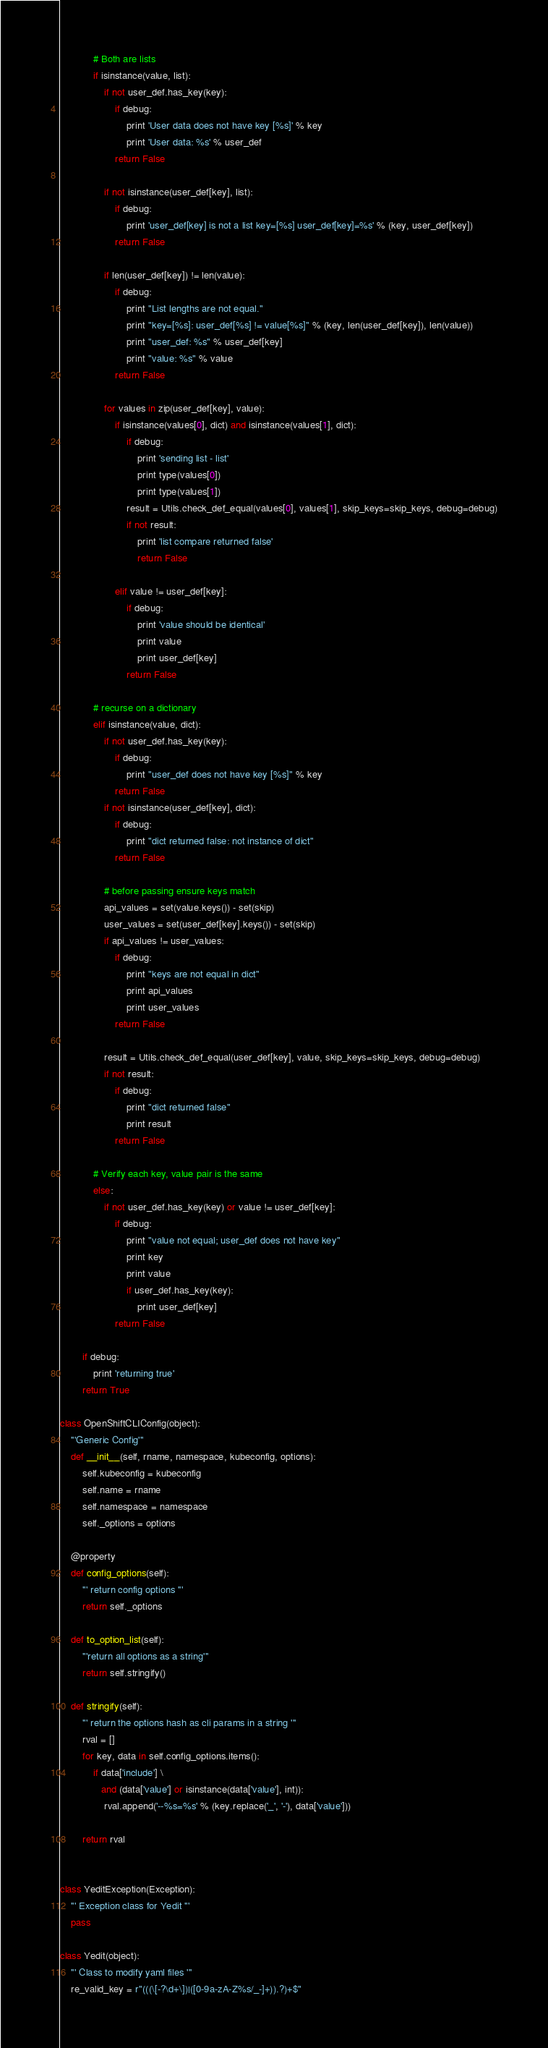Convert code to text. <code><loc_0><loc_0><loc_500><loc_500><_Python_>            # Both are lists
            if isinstance(value, list):
                if not user_def.has_key(key):
                    if debug:
                        print 'User data does not have key [%s]' % key
                        print 'User data: %s' % user_def
                    return False

                if not isinstance(user_def[key], list):
                    if debug:
                        print 'user_def[key] is not a list key=[%s] user_def[key]=%s' % (key, user_def[key])
                    return False

                if len(user_def[key]) != len(value):
                    if debug:
                        print "List lengths are not equal."
                        print "key=[%s]: user_def[%s] != value[%s]" % (key, len(user_def[key]), len(value))
                        print "user_def: %s" % user_def[key]
                        print "value: %s" % value
                    return False

                for values in zip(user_def[key], value):
                    if isinstance(values[0], dict) and isinstance(values[1], dict):
                        if debug:
                            print 'sending list - list'
                            print type(values[0])
                            print type(values[1])
                        result = Utils.check_def_equal(values[0], values[1], skip_keys=skip_keys, debug=debug)
                        if not result:
                            print 'list compare returned false'
                            return False

                    elif value != user_def[key]:
                        if debug:
                            print 'value should be identical'
                            print value
                            print user_def[key]
                        return False

            # recurse on a dictionary
            elif isinstance(value, dict):
                if not user_def.has_key(key):
                    if debug:
                        print "user_def does not have key [%s]" % key
                    return False
                if not isinstance(user_def[key], dict):
                    if debug:
                        print "dict returned false: not instance of dict"
                    return False

                # before passing ensure keys match
                api_values = set(value.keys()) - set(skip)
                user_values = set(user_def[key].keys()) - set(skip)
                if api_values != user_values:
                    if debug:
                        print "keys are not equal in dict"
                        print api_values
                        print user_values
                    return False

                result = Utils.check_def_equal(user_def[key], value, skip_keys=skip_keys, debug=debug)
                if not result:
                    if debug:
                        print "dict returned false"
                        print result
                    return False

            # Verify each key, value pair is the same
            else:
                if not user_def.has_key(key) or value != user_def[key]:
                    if debug:
                        print "value not equal; user_def does not have key"
                        print key
                        print value
                        if user_def.has_key(key):
                            print user_def[key]
                    return False

        if debug:
            print 'returning true'
        return True

class OpenShiftCLIConfig(object):
    '''Generic Config'''
    def __init__(self, rname, namespace, kubeconfig, options):
        self.kubeconfig = kubeconfig
        self.name = rname
        self.namespace = namespace
        self._options = options

    @property
    def config_options(self):
        ''' return config options '''
        return self._options

    def to_option_list(self):
        '''return all options as a string'''
        return self.stringify()

    def stringify(self):
        ''' return the options hash as cli params in a string '''
        rval = []
        for key, data in self.config_options.items():
            if data['include'] \
               and (data['value'] or isinstance(data['value'], int)):
                rval.append('--%s=%s' % (key.replace('_', '-'), data['value']))

        return rval


class YeditException(Exception):
    ''' Exception class for Yedit '''
    pass

class Yedit(object):
    ''' Class to modify yaml files '''
    re_valid_key = r"(((\[-?\d+\])|([0-9a-zA-Z%s/_-]+)).?)+$"</code> 